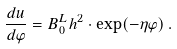<formula> <loc_0><loc_0><loc_500><loc_500>\frac { d u } { d \varphi } = B _ { 0 } ^ { L } h ^ { 2 } \cdot \exp ( - \eta \varphi ) \, .</formula> 